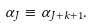<formula> <loc_0><loc_0><loc_500><loc_500>\alpha _ { J } \equiv \alpha _ { J + k + 1 } .</formula> 